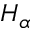<formula> <loc_0><loc_0><loc_500><loc_500>H _ { \alpha }</formula> 